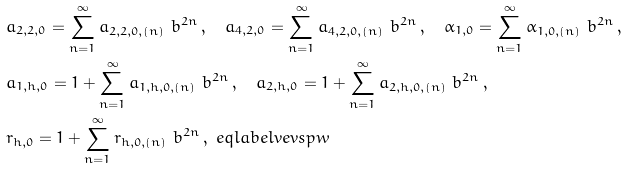Convert formula to latex. <formula><loc_0><loc_0><loc_500><loc_500>& a _ { 2 , 2 , 0 } = \sum _ { n = 1 } ^ { \infty } a _ { 2 , 2 , 0 , ( n ) } \ b ^ { 2 n } \, , \quad a _ { 4 , 2 , 0 } = \sum _ { n = 1 } ^ { \infty } a _ { 4 , 2 , 0 , ( n ) } \ b ^ { 2 n } \, , \quad \alpha _ { 1 , 0 } = \sum _ { n = 1 } ^ { \infty } \alpha _ { 1 , 0 , ( n ) } \ b ^ { 2 n } \, , \\ & a _ { 1 , h , 0 } = 1 + \sum _ { n = 1 } ^ { \infty } a _ { 1 , h , 0 , ( n ) } \ b ^ { 2 n } \, , \quad a _ { 2 , h , 0 } = 1 + \sum _ { n = 1 } ^ { \infty } a _ { 2 , h , 0 , ( n ) } \ b ^ { 2 n } \, , \\ & r _ { h , 0 } = 1 + \sum _ { n = 1 } ^ { \infty } r _ { h , 0 , ( n ) } \ b ^ { 2 n } \, , \ e q l a b e l { v e v s p w }</formula> 